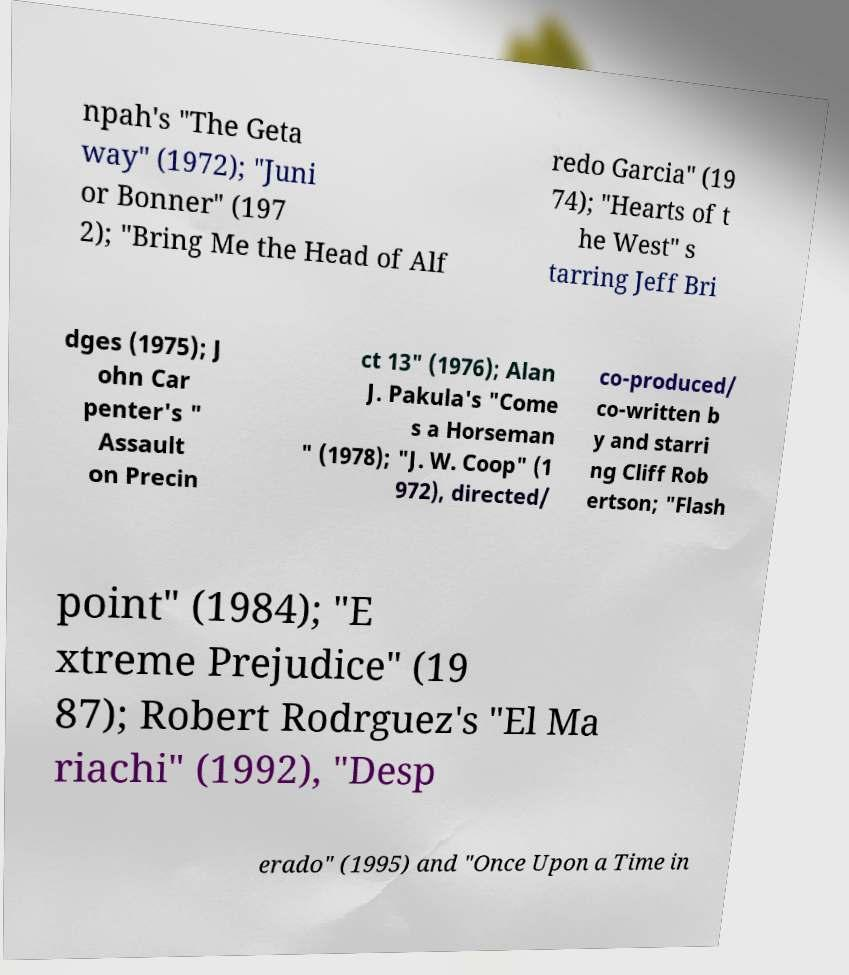Please identify and transcribe the text found in this image. npah's "The Geta way" (1972); "Juni or Bonner" (197 2); "Bring Me the Head of Alf redo Garcia" (19 74); "Hearts of t he West" s tarring Jeff Bri dges (1975); J ohn Car penter's " Assault on Precin ct 13" (1976); Alan J. Pakula's "Come s a Horseman " (1978); "J. W. Coop" (1 972), directed/ co-produced/ co-written b y and starri ng Cliff Rob ertson; "Flash point" (1984); "E xtreme Prejudice" (19 87); Robert Rodrguez's "El Ma riachi" (1992), "Desp erado" (1995) and "Once Upon a Time in 